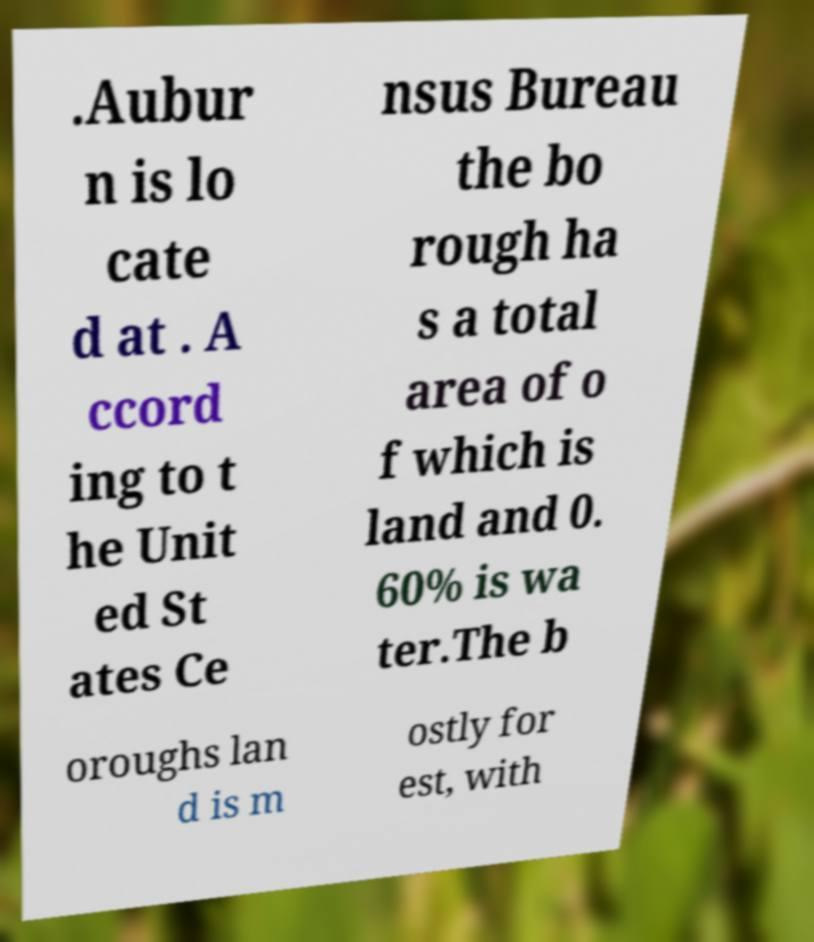Could you extract and type out the text from this image? .Aubur n is lo cate d at . A ccord ing to t he Unit ed St ates Ce nsus Bureau the bo rough ha s a total area of o f which is land and 0. 60% is wa ter.The b oroughs lan d is m ostly for est, with 